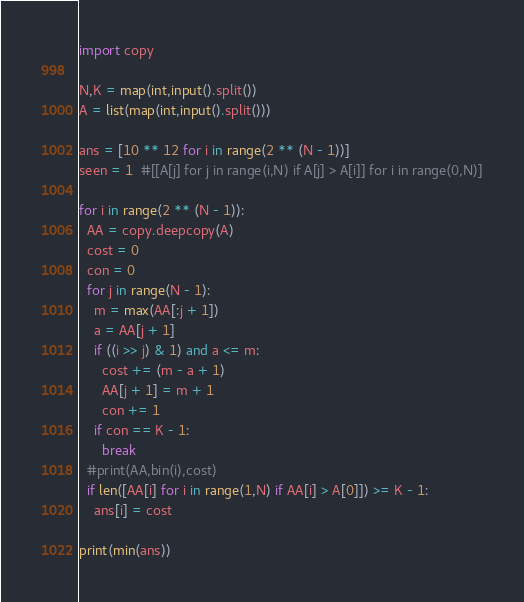Convert code to text. <code><loc_0><loc_0><loc_500><loc_500><_Python_>import copy

N,K = map(int,input().split())
A = list(map(int,input().split()))

ans = [10 ** 12 for i in range(2 ** (N - 1))]
seen = 1  #[[A[j] for j in range(i,N) if A[j] > A[i]] for i in range(0,N)]

for i in range(2 ** (N - 1)):
  AA = copy.deepcopy(A)
  cost = 0
  con = 0
  for j in range(N - 1):
    m = max(AA[:j + 1])
    a = AA[j + 1]
    if ((i >> j) & 1) and a <= m:
      cost += (m - a + 1)
      AA[j + 1] = m + 1
      con += 1
    if con == K - 1:
      break
  #print(AA,bin(i),cost)
  if len([AA[i] for i in range(1,N) if AA[i] > A[0]]) >= K - 1:
    ans[i] = cost
  
print(min(ans))</code> 